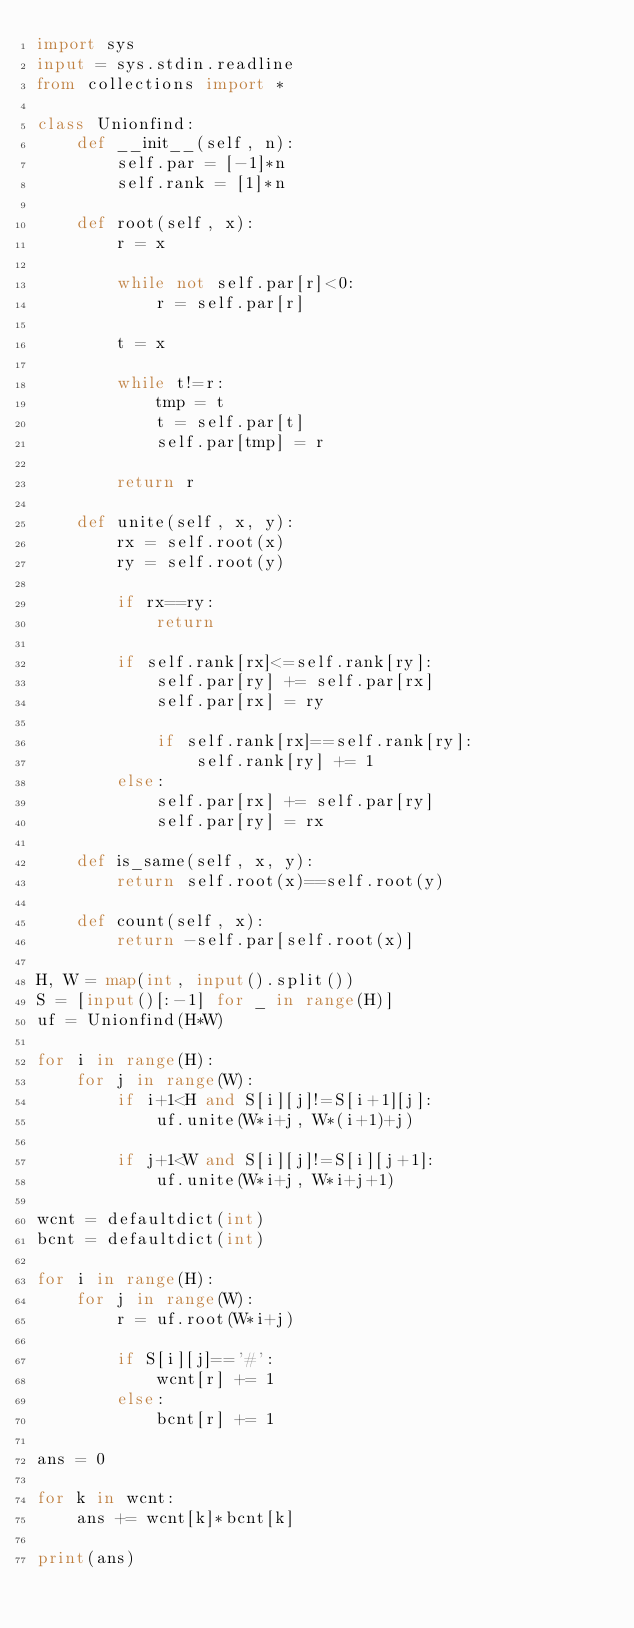Convert code to text. <code><loc_0><loc_0><loc_500><loc_500><_Python_>import sys
input = sys.stdin.readline
from collections import *

class Unionfind:
    def __init__(self, n):
        self.par = [-1]*n
        self.rank = [1]*n
    
    def root(self, x):
        r = x
        
        while not self.par[r]<0:
            r = self.par[r]
        
        t = x
        
        while t!=r:
            tmp = t
            t = self.par[t]
            self.par[tmp] = r
        
        return r
    
    def unite(self, x, y):
        rx = self.root(x)
        ry = self.root(y)
        
        if rx==ry:
            return
        
        if self.rank[rx]<=self.rank[ry]:
            self.par[ry] += self.par[rx]
            self.par[rx] = ry
            
            if self.rank[rx]==self.rank[ry]:
                self.rank[ry] += 1
        else:
            self.par[rx] += self.par[ry]
            self.par[ry] = rx
    
    def is_same(self, x, y):
        return self.root(x)==self.root(y)
    
    def count(self, x):
        return -self.par[self.root(x)]

H, W = map(int, input().split())
S = [input()[:-1] for _ in range(H)]
uf = Unionfind(H*W)

for i in range(H):
    for j in range(W):
        if i+1<H and S[i][j]!=S[i+1][j]:
            uf.unite(W*i+j, W*(i+1)+j)
            
        if j+1<W and S[i][j]!=S[i][j+1]:
            uf.unite(W*i+j, W*i+j+1)

wcnt = defaultdict(int)
bcnt = defaultdict(int)

for i in range(H):
    for j in range(W):
        r = uf.root(W*i+j)
        
        if S[i][j]=='#':
            wcnt[r] += 1
        else:
            bcnt[r] += 1

ans = 0

for k in wcnt:
    ans += wcnt[k]*bcnt[k]

print(ans)</code> 